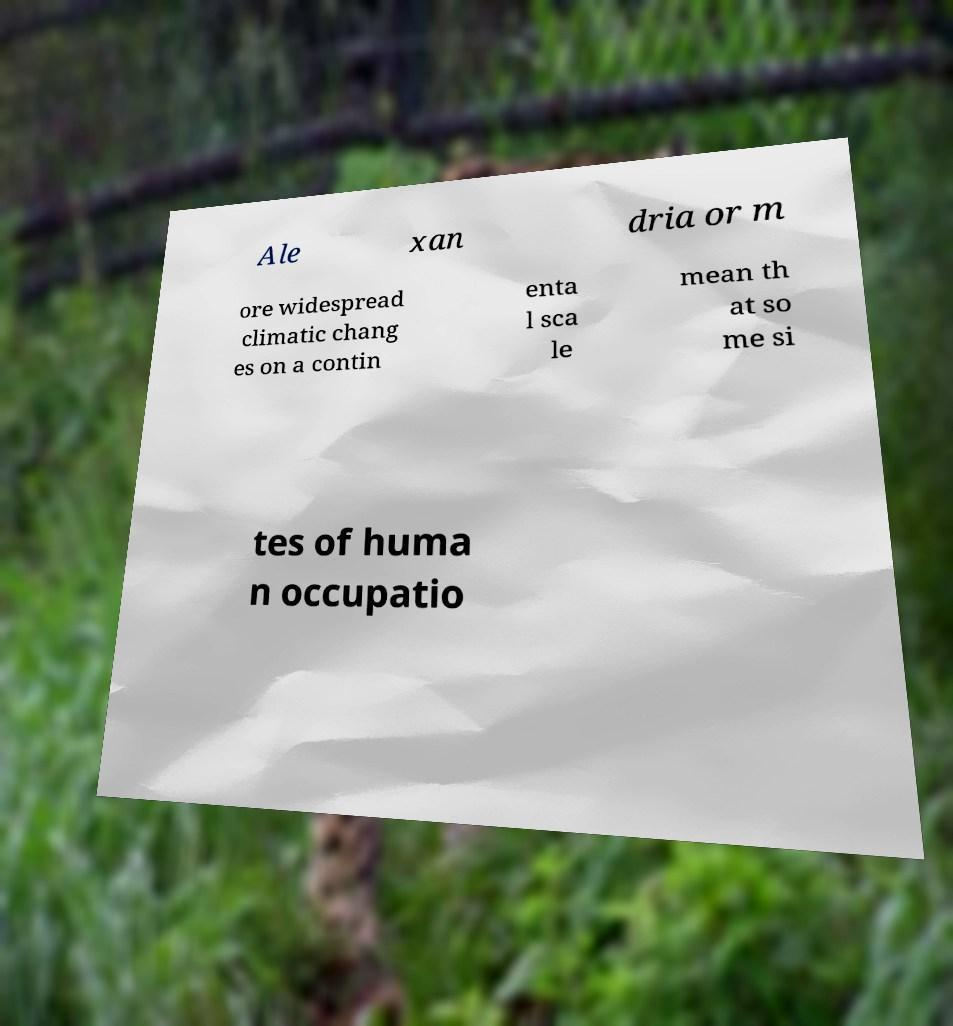Could you extract and type out the text from this image? Ale xan dria or m ore widespread climatic chang es on a contin enta l sca le mean th at so me si tes of huma n occupatio 